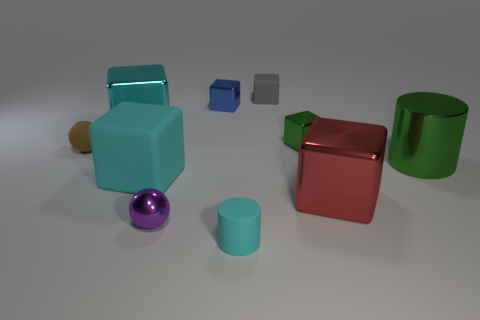What lighting conditions are suggested by the shadows and highlights in the image? The shadows and highlights suggest diffuse overhead lighting, resulting in soft shadows cast by the objects onto the surface below them. 